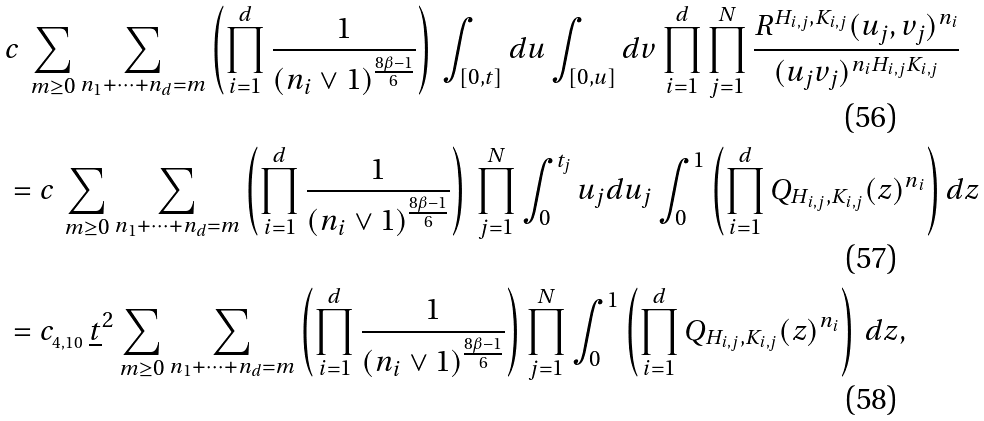<formula> <loc_0><loc_0><loc_500><loc_500>& c \, \sum _ { m \geq 0 } \sum _ { n _ { 1 } + \cdots + n _ { d } = m } \left ( \prod _ { i = 1 } ^ { d } \frac { 1 } { ( n _ { i } \vee 1 ) ^ { \frac { 8 \beta - 1 } { 6 } } } \right ) \, \int _ { [ 0 , t ] } d u \int _ { [ 0 , u ] } d v \prod _ { i = 1 } ^ { d } \prod _ { j = 1 } ^ { N } \frac { R ^ { H _ { i , j } , K _ { i , j } } ( u _ { j } , v _ { j } ) ^ { n _ { i } } } { ( u _ { j } v _ { j } ) ^ { n _ { i } H _ { i , j } K _ { i , j } } } \\ & = c \, \sum _ { m \geq 0 } \sum _ { n _ { 1 } + \cdots + n _ { d } = m } \left ( \prod _ { i = 1 } ^ { d } \frac { 1 } { ( n _ { i } \vee 1 ) ^ { \frac { 8 \beta - 1 } { 6 } } } \right ) \, \prod _ { j = 1 } ^ { N } \int _ { 0 } ^ { t _ { j } } u _ { j } d u _ { j } \int _ { 0 } ^ { 1 } \left ( \prod _ { i = 1 } ^ { d } Q _ { H _ { i , j } , K _ { i , j } } ( z ) ^ { n _ { i } } \right ) d z \\ & = c _ { _ { 4 , 1 0 } } \, \underline { t } ^ { 2 } \sum _ { m \geq 0 } \sum _ { n _ { 1 } + \cdots + n _ { d } = m } \left ( \prod _ { i = 1 } ^ { d } \frac { 1 } { ( n _ { i } \vee 1 ) ^ { \frac { 8 \beta - 1 } { 6 } } } \right ) \prod _ { j = 1 } ^ { N } \int _ { 0 } ^ { 1 } \left ( \prod _ { i = 1 } ^ { d } Q _ { H _ { i , j } , K _ { i , j } } ( z ) ^ { n _ { i } } \right ) \, d z ,</formula> 